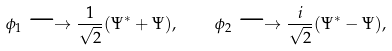<formula> <loc_0><loc_0><loc_500><loc_500>\phi _ { 1 } \longrightarrow \frac { 1 } { \sqrt { 2 } } ( \Psi ^ { \ast } + \Psi ) , \quad \phi _ { 2 } \longrightarrow \frac { i } { \sqrt { 2 } } ( \Psi ^ { \ast } - \Psi ) ,</formula> 